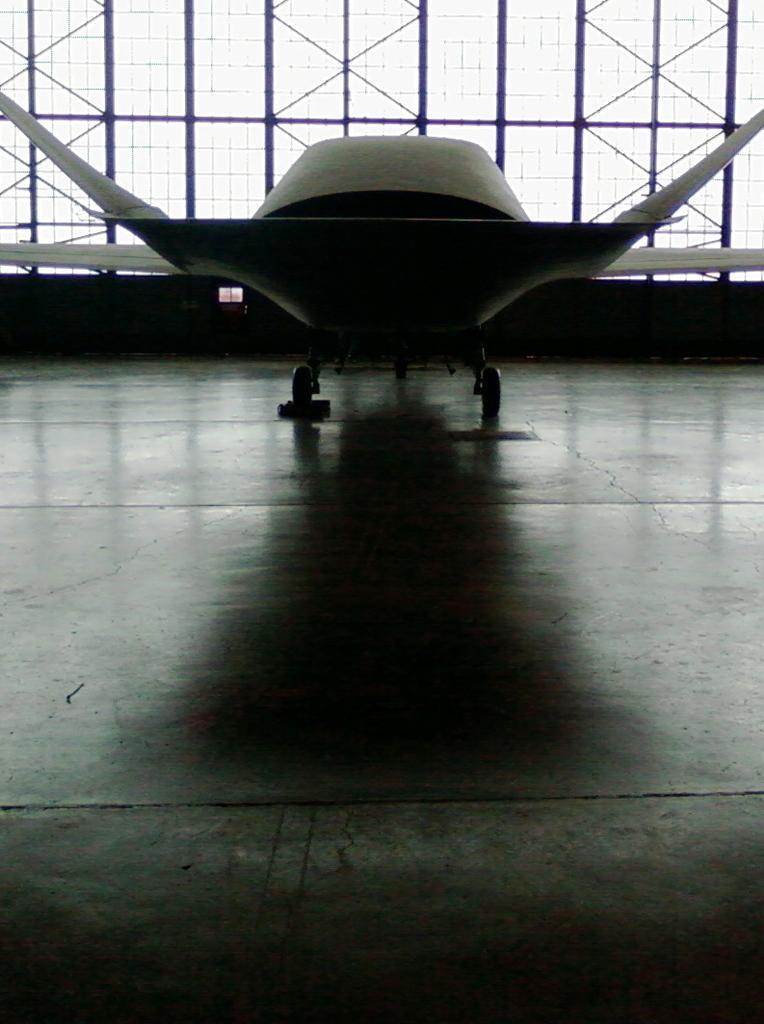In one or two sentences, can you explain what this image depicts? In this image in the background there is an airplane and there are windows. 